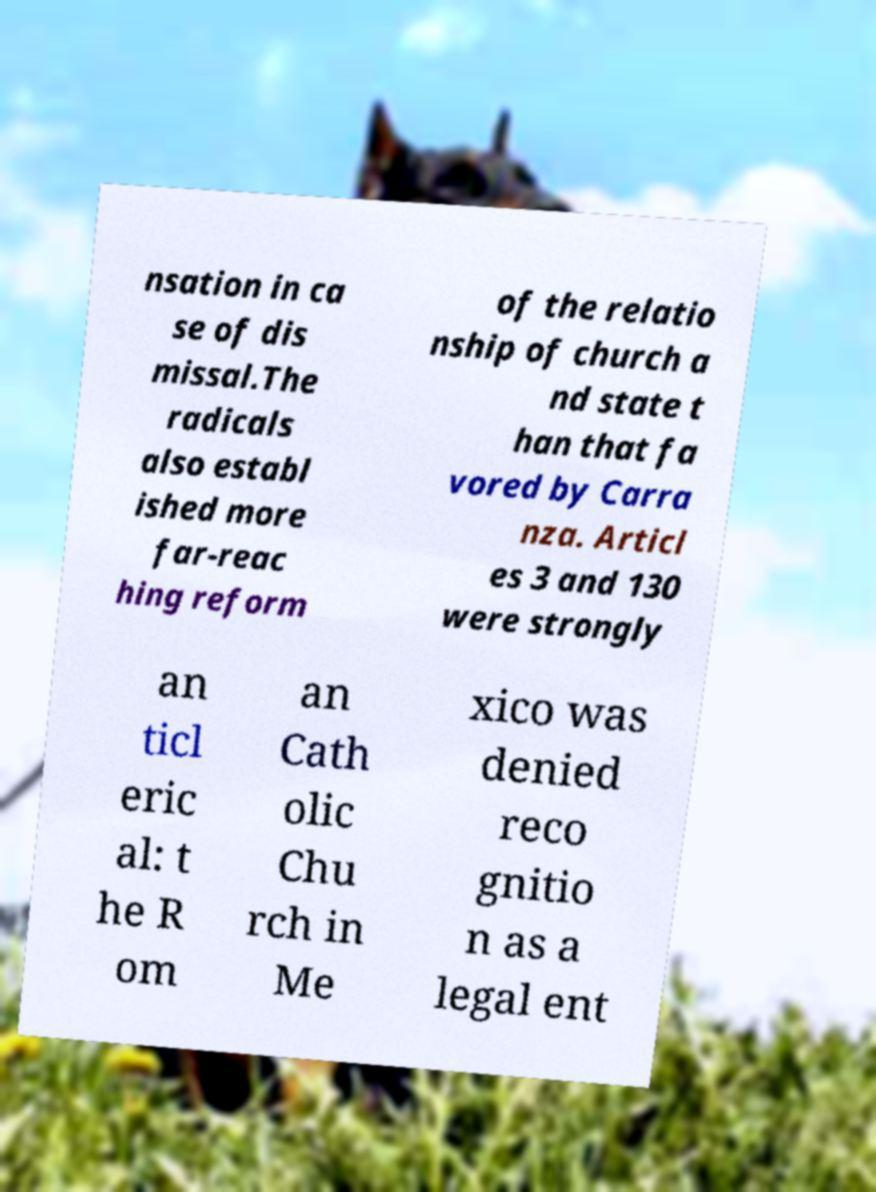Please read and relay the text visible in this image. What does it say? nsation in ca se of dis missal.The radicals also establ ished more far-reac hing reform of the relatio nship of church a nd state t han that fa vored by Carra nza. Articl es 3 and 130 were strongly an ticl eric al: t he R om an Cath olic Chu rch in Me xico was denied reco gnitio n as a legal ent 